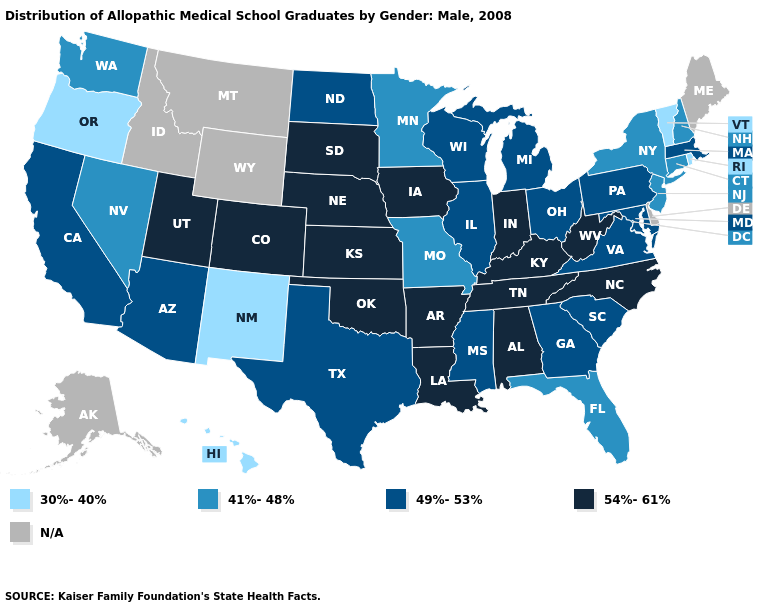Does Florida have the lowest value in the South?
Short answer required. Yes. What is the value of Florida?
Concise answer only. 41%-48%. What is the highest value in the USA?
Be succinct. 54%-61%. Name the states that have a value in the range 41%-48%?
Answer briefly. Connecticut, Florida, Minnesota, Missouri, Nevada, New Hampshire, New Jersey, New York, Washington. Does the map have missing data?
Write a very short answer. Yes. What is the highest value in the USA?
Short answer required. 54%-61%. How many symbols are there in the legend?
Give a very brief answer. 5. Name the states that have a value in the range N/A?
Write a very short answer. Alaska, Delaware, Idaho, Maine, Montana, Wyoming. Name the states that have a value in the range 41%-48%?
Be succinct. Connecticut, Florida, Minnesota, Missouri, Nevada, New Hampshire, New Jersey, New York, Washington. Does Florida have the lowest value in the South?
Be succinct. Yes. What is the value of Wyoming?
Keep it brief. N/A. Among the states that border Indiana , which have the lowest value?
Quick response, please. Illinois, Michigan, Ohio. Name the states that have a value in the range 41%-48%?
Answer briefly. Connecticut, Florida, Minnesota, Missouri, Nevada, New Hampshire, New Jersey, New York, Washington. Among the states that border Connecticut , which have the highest value?
Give a very brief answer. Massachusetts. 